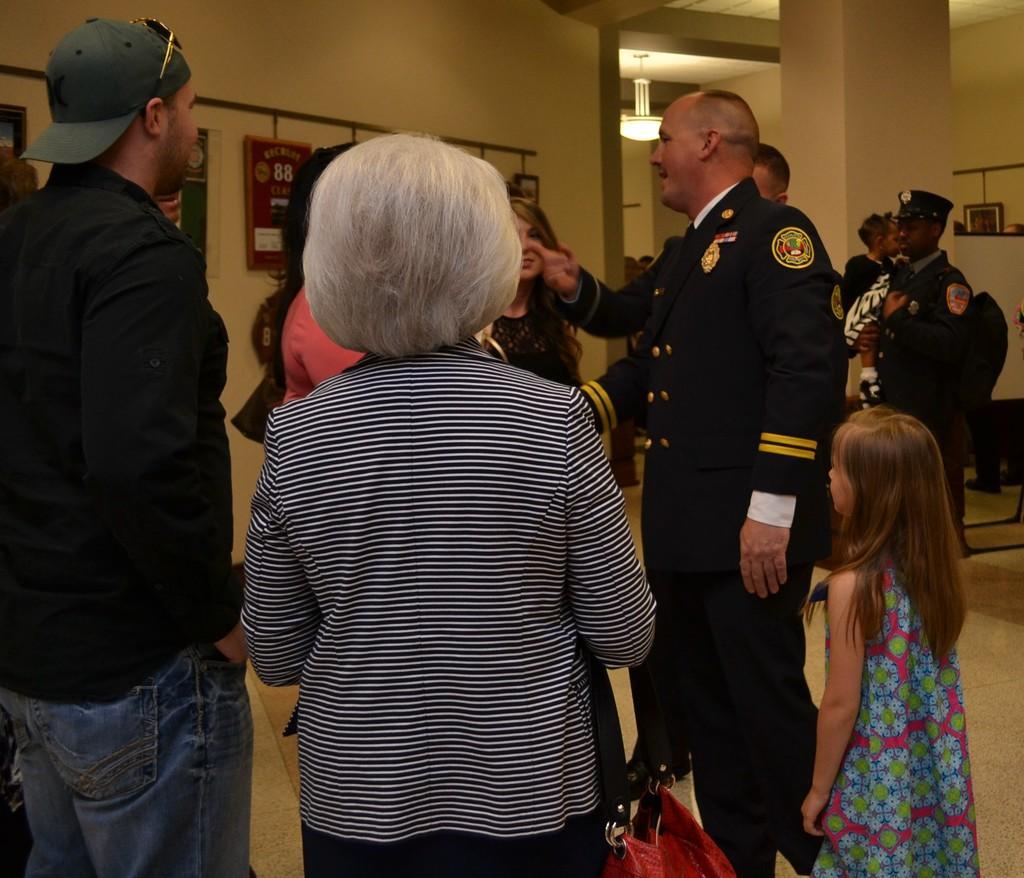Please provide a concise description of this image. This image is clicked in a room. There are many persons standing in the room. In the front, the person standing is wearing black and white shirt. To the left, the man is wearing black shirt and green cap. In the background, there are walls along with pillars. At the bottom, there is a floor. 